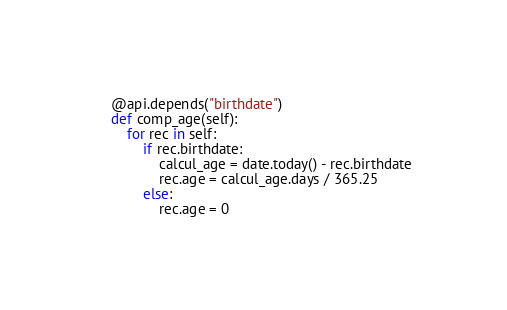<code> <loc_0><loc_0><loc_500><loc_500><_Python_>    @api.depends("birthdate")
    def comp_age(self):
        for rec in self:
            if rec.birthdate:
                calcul_age = date.today() - rec.birthdate
                rec.age = calcul_age.days / 365.25
            else:
                rec.age = 0
</code> 